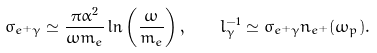Convert formula to latex. <formula><loc_0><loc_0><loc_500><loc_500>\sigma _ { e ^ { + } \gamma } \simeq \frac { \pi \alpha ^ { 2 } } { \omega m _ { e } } \ln \left ( \frac { \omega } { m _ { e } } \right ) , \quad l _ { \gamma } ^ { - 1 } \simeq \sigma _ { e ^ { + } \gamma } n _ { e ^ { + } } ( \omega _ { p } ) .</formula> 